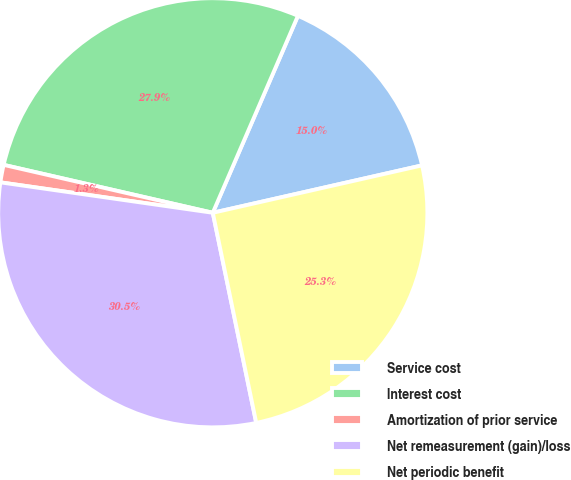Convert chart. <chart><loc_0><loc_0><loc_500><loc_500><pie_chart><fcel>Service cost<fcel>Interest cost<fcel>Amortization of prior service<fcel>Net remeasurement (gain)/loss<fcel>Net periodic benefit<nl><fcel>14.96%<fcel>27.91%<fcel>1.32%<fcel>30.51%<fcel>25.3%<nl></chart> 